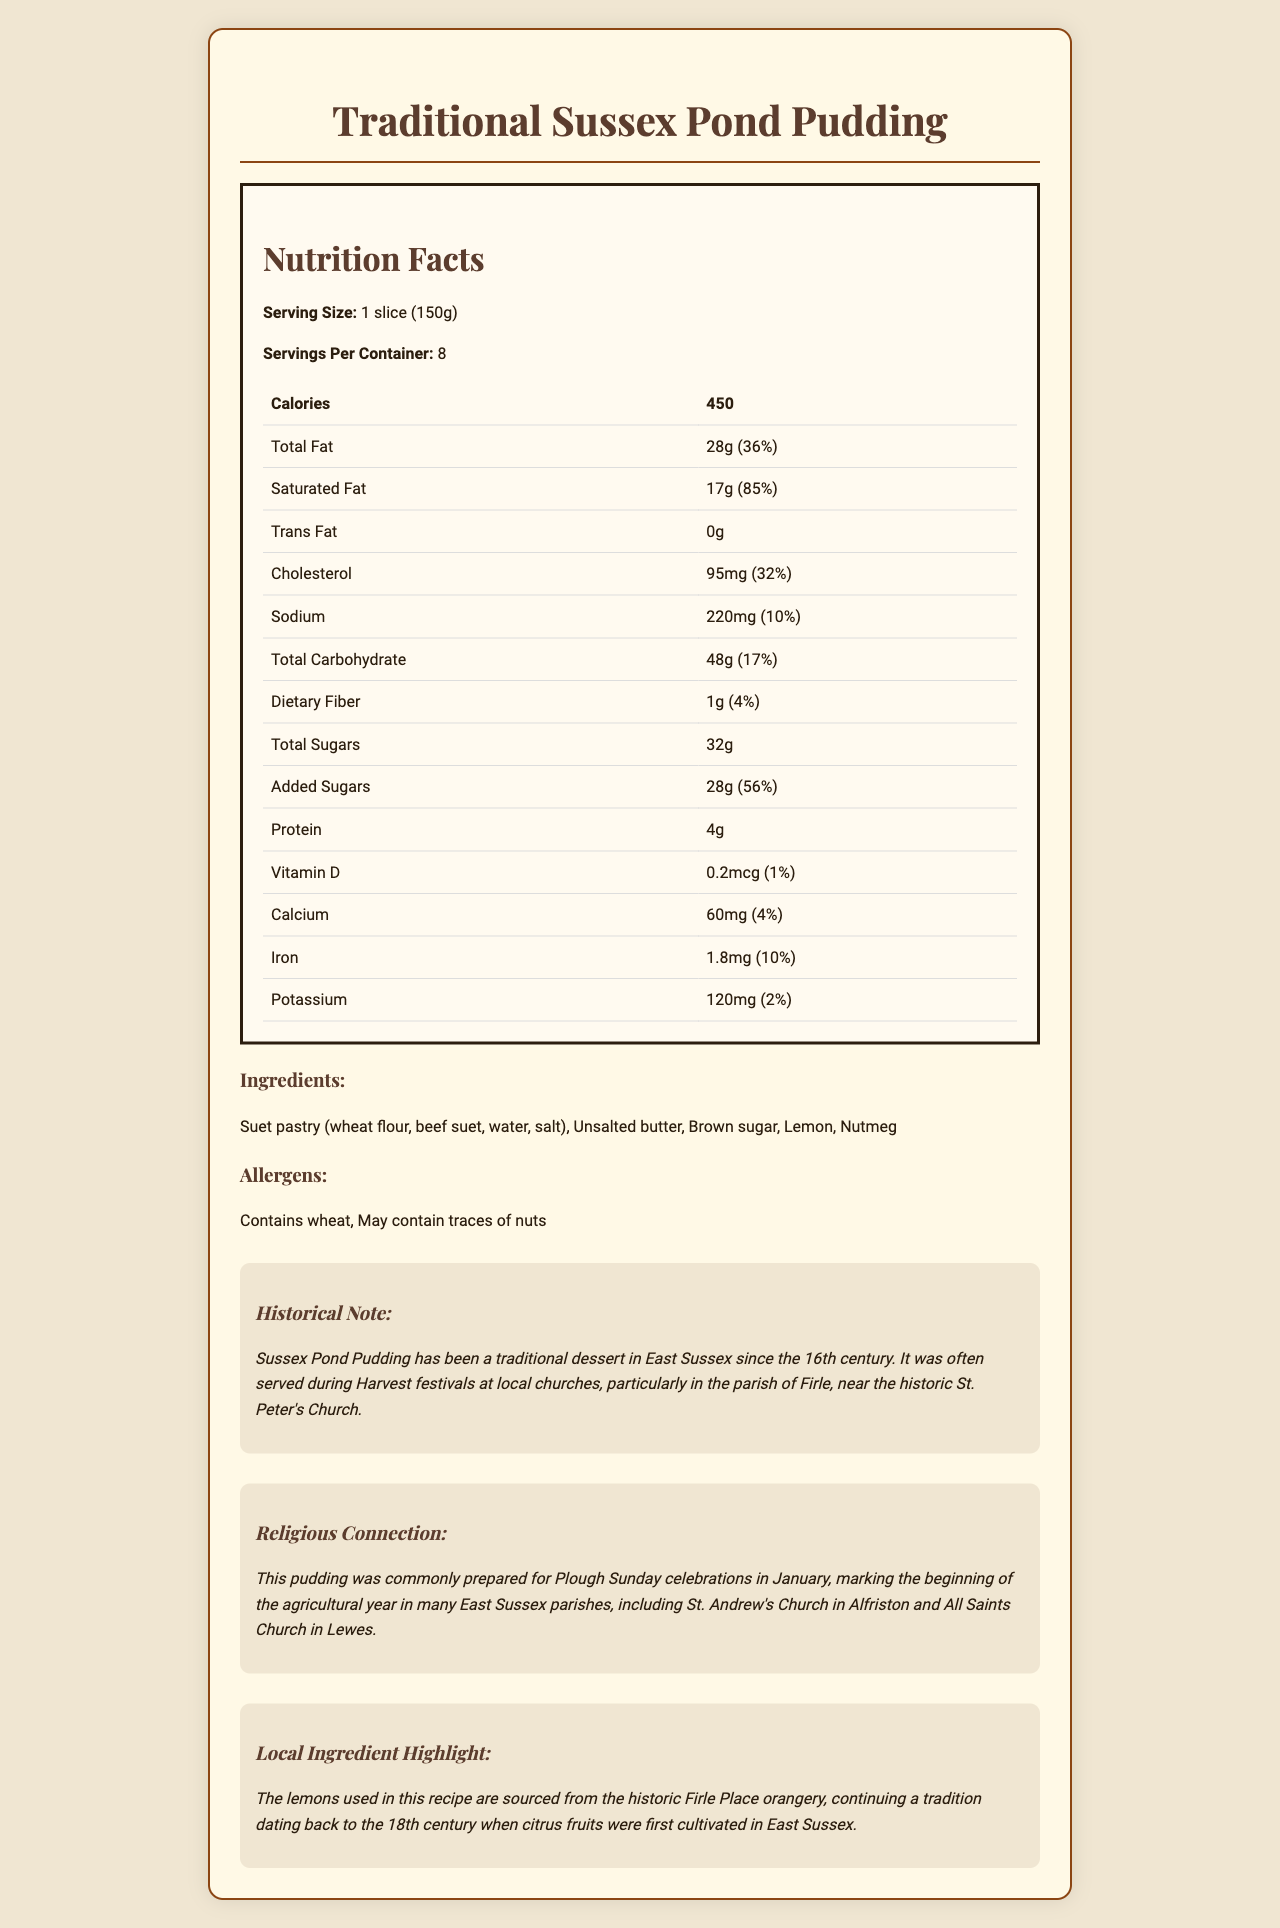what is the serving size of the Sussex Pond Pudding? The document clearly lists the serving size as "1 slice (150g)."
Answer: 1 slice (150g) how many calories are in one serving? The document specifies that each serving contains 450 calories.
Answer: 450 what allergens are present in this pudding? The allergens listed in the document are wheat and potential traces of nuts.
Answer: Contains wheat, May contain traces of nuts how much total fat does one serving contain? The document indicates that one serving of the pudding contains 28g of total fat.
Answer: 28g what is the percentage of daily value of saturated fat per serving? According to the document, the daily value percentage for saturated fat is 85%.
Answer: 85% which vitamins and minerals are present in smallest amounts per serving? A. Vitamin D B. Calcium C. Iron D. Potassium The document shows that Vitamin D is available in the smallest amount per serving (0.2mcg, 1% DV).
Answer: A. Vitamin D how many grams of added sugars are in one serving? A. 20g B. 26g C. 28g D. 32g The document states that there are 28g of added sugars per serving.
Answer: C. 28g does the document mention the historical significance of Sussex Pond Pudding? The document includes a historical note stating that Sussex Pond Pudding has been a traditional dessert in East Sussex since the 16th century and was often served during Harvest festivals at local churches.
Answer: Yes what is the primary source of lemons used in this pudding? The document notes that the lemons are sourced from the historic Firle Place orangery.
Answer: Firle Place orangery how many grams of protein are there in one serving? The document states that there are 4g of protein in one serving.
Answer: 4g for which religious event was this pudding traditionally prepared? The document states that Sussex Pond Pudding was commonly prepared for Plough Sunday celebrations in January.
Answer: Plough Sunday celebrations what type of ingredient is suet pastry composed of? The document lists the ingredients of suet pastry as wheat flour, beef suet, water, and salt.
Answer: Wheat flour, beef suet, water, salt which historic church in Firle is associated with this pudding? The historical note mentions the association with St. Peter’s Church in Firle.
Answer: St. Peter's Church how many servings are there per container? A. 6 B. 7 C. 8 D. 9 The document specifies that there are 8 servings per container.
Answer: C. 8 is there any trans fat in one serving of this pudding? The document shows that there is 0g of trans fat per serving.
Answer: No (0g) what is the main idea of the document? The document presents detailed nutrition information, ingredients, allergens, and historical and local significance of Sussex Pond Pudding.
Answer: Nutrition facts and historical significance of Sussex Pond Pudding does the pudding contain any almonds? The document only states that it contains wheat and may contain traces of nuts but does not specify almonds.
Answer: Not enough information where is Sussex Pond Pudding often served during religious festivals? A. St. Peter's Church B. St. Mary's Church C. St. Martin's Church The document mentions that it was often served at Harvest festivals at local churches, particularly in the parish of Firle, near the historic St. Peter’s Church.
Answer: A. St. Peter's Church 